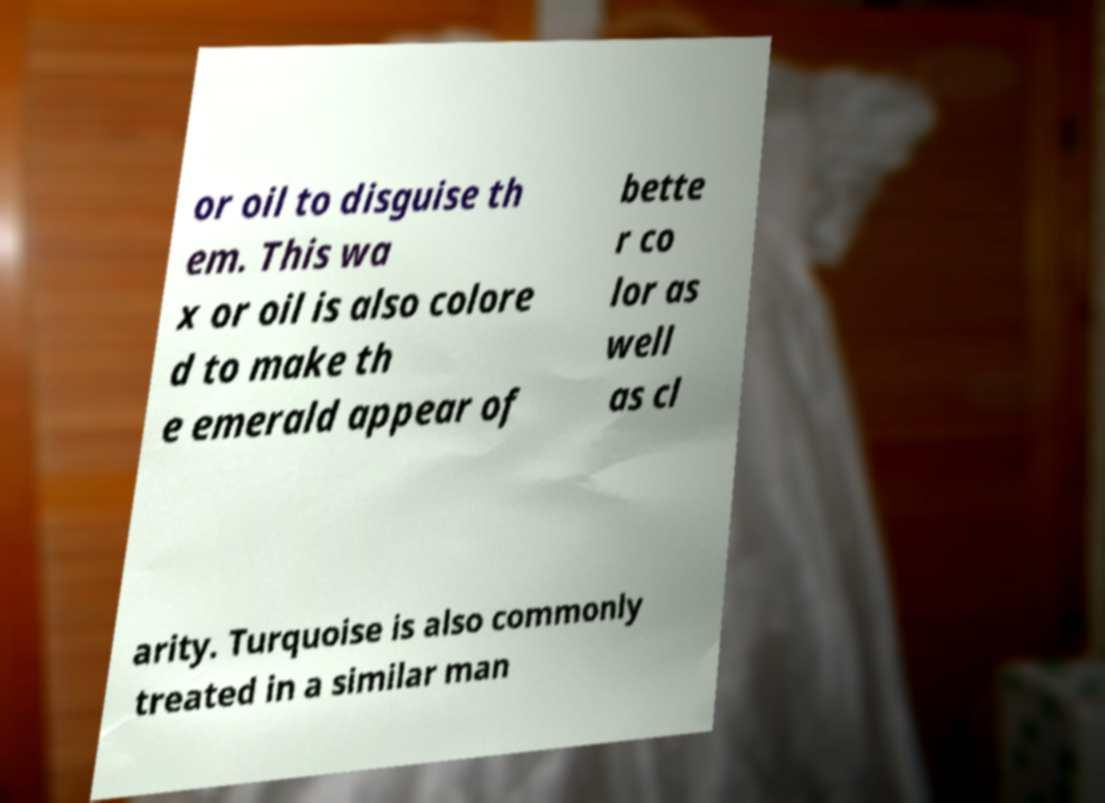What messages or text are displayed in this image? I need them in a readable, typed format. or oil to disguise th em. This wa x or oil is also colore d to make th e emerald appear of bette r co lor as well as cl arity. Turquoise is also commonly treated in a similar man 